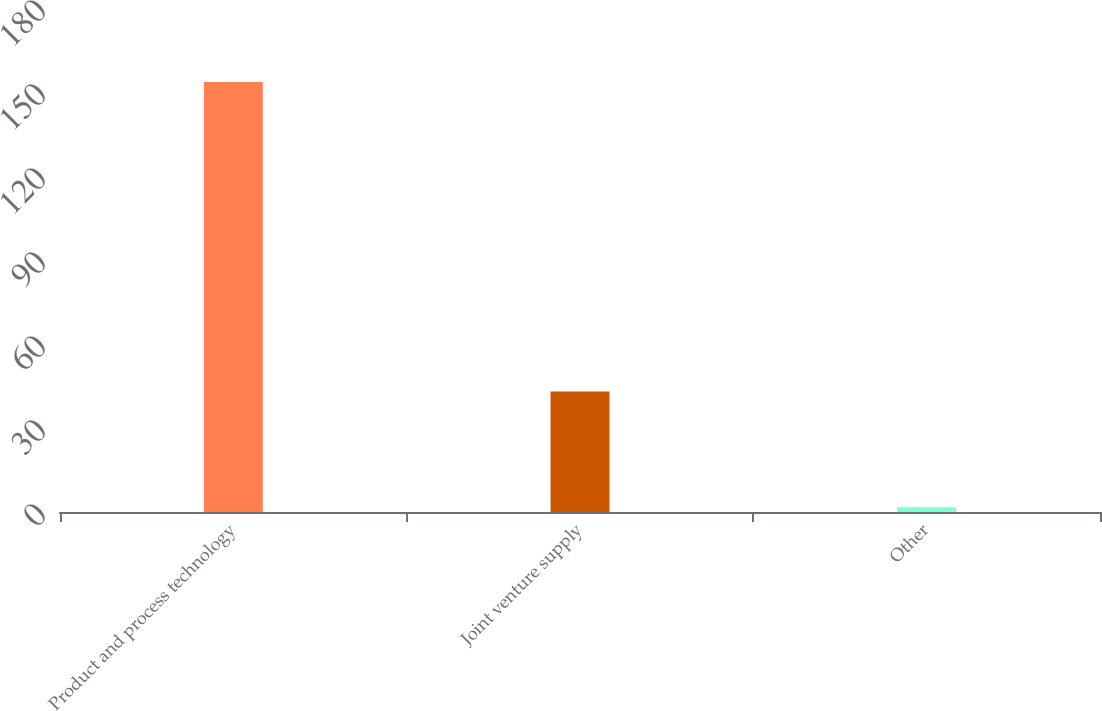Convert chart. <chart><loc_0><loc_0><loc_500><loc_500><bar_chart><fcel>Product and process technology<fcel>Joint venture supply<fcel>Other<nl><fcel>153.6<fcel>43<fcel>1.7<nl></chart> 